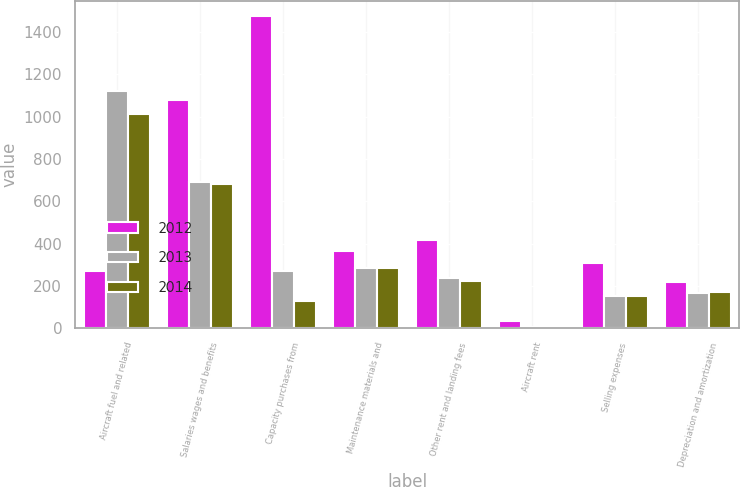<chart> <loc_0><loc_0><loc_500><loc_500><stacked_bar_chart><ecel><fcel>Aircraft fuel and related<fcel>Salaries wages and benefits<fcel>Capacity purchases from<fcel>Maintenance materials and<fcel>Other rent and landing fees<fcel>Aircraft rent<fcel>Selling expenses<fcel>Depreciation and amortization<nl><fcel>2012<fcel>269<fcel>1078<fcel>1475<fcel>367<fcel>419<fcel>35<fcel>307<fcel>217<nl><fcel>2013<fcel>1120<fcel>692<fcel>269<fcel>284<fcel>236<fcel>4<fcel>154<fcel>168<nl><fcel>2014<fcel>1012<fcel>681<fcel>129<fcel>285<fcel>222<fcel>6<fcel>152<fcel>170<nl></chart> 